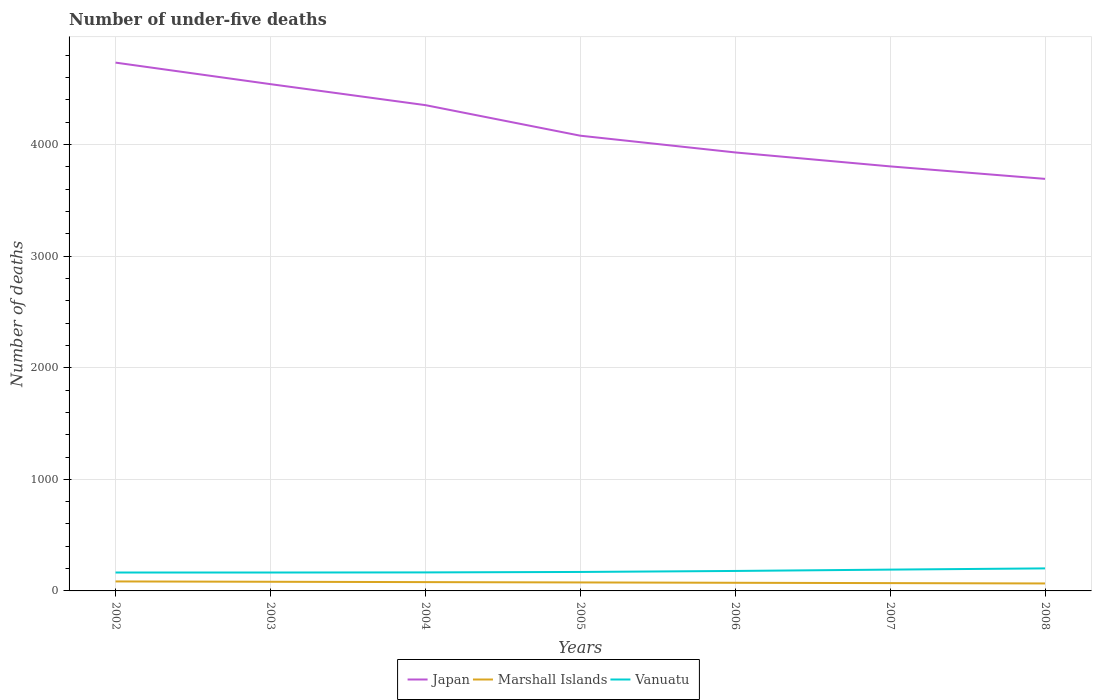Does the line corresponding to Japan intersect with the line corresponding to Vanuatu?
Offer a terse response. No. Across all years, what is the maximum number of under-five deaths in Marshall Islands?
Your answer should be compact. 67. In which year was the number of under-five deaths in Japan maximum?
Give a very brief answer. 2008. What is the difference between the highest and the second highest number of under-five deaths in Marshall Islands?
Your answer should be compact. 18. What is the difference between the highest and the lowest number of under-five deaths in Vanuatu?
Provide a short and direct response. 3. What is the difference between two consecutive major ticks on the Y-axis?
Offer a very short reply. 1000. Where does the legend appear in the graph?
Provide a succinct answer. Bottom center. How many legend labels are there?
Offer a terse response. 3. How are the legend labels stacked?
Your answer should be very brief. Horizontal. What is the title of the graph?
Make the answer very short. Number of under-five deaths. What is the label or title of the X-axis?
Give a very brief answer. Years. What is the label or title of the Y-axis?
Your response must be concise. Number of deaths. What is the Number of deaths of Japan in 2002?
Give a very brief answer. 4735. What is the Number of deaths of Vanuatu in 2002?
Your answer should be compact. 165. What is the Number of deaths of Japan in 2003?
Make the answer very short. 4542. What is the Number of deaths of Vanuatu in 2003?
Provide a succinct answer. 165. What is the Number of deaths of Japan in 2004?
Ensure brevity in your answer.  4354. What is the Number of deaths of Marshall Islands in 2004?
Provide a succinct answer. 79. What is the Number of deaths of Vanuatu in 2004?
Provide a short and direct response. 166. What is the Number of deaths in Japan in 2005?
Offer a very short reply. 4080. What is the Number of deaths in Marshall Islands in 2005?
Give a very brief answer. 76. What is the Number of deaths of Vanuatu in 2005?
Provide a succinct answer. 170. What is the Number of deaths in Japan in 2006?
Ensure brevity in your answer.  3930. What is the Number of deaths of Marshall Islands in 2006?
Provide a short and direct response. 73. What is the Number of deaths in Vanuatu in 2006?
Your answer should be compact. 179. What is the Number of deaths in Japan in 2007?
Your response must be concise. 3805. What is the Number of deaths of Vanuatu in 2007?
Give a very brief answer. 191. What is the Number of deaths in Japan in 2008?
Your answer should be compact. 3693. What is the Number of deaths in Vanuatu in 2008?
Your response must be concise. 202. Across all years, what is the maximum Number of deaths in Japan?
Ensure brevity in your answer.  4735. Across all years, what is the maximum Number of deaths of Vanuatu?
Your answer should be very brief. 202. Across all years, what is the minimum Number of deaths of Japan?
Ensure brevity in your answer.  3693. Across all years, what is the minimum Number of deaths in Vanuatu?
Your answer should be compact. 165. What is the total Number of deaths of Japan in the graph?
Provide a succinct answer. 2.91e+04. What is the total Number of deaths of Marshall Islands in the graph?
Your answer should be compact. 532. What is the total Number of deaths in Vanuatu in the graph?
Your answer should be very brief. 1238. What is the difference between the Number of deaths in Japan in 2002 and that in 2003?
Your response must be concise. 193. What is the difference between the Number of deaths in Japan in 2002 and that in 2004?
Your response must be concise. 381. What is the difference between the Number of deaths in Japan in 2002 and that in 2005?
Keep it short and to the point. 655. What is the difference between the Number of deaths in Vanuatu in 2002 and that in 2005?
Your answer should be very brief. -5. What is the difference between the Number of deaths of Japan in 2002 and that in 2006?
Ensure brevity in your answer.  805. What is the difference between the Number of deaths in Marshall Islands in 2002 and that in 2006?
Ensure brevity in your answer.  12. What is the difference between the Number of deaths in Vanuatu in 2002 and that in 2006?
Your answer should be very brief. -14. What is the difference between the Number of deaths in Japan in 2002 and that in 2007?
Make the answer very short. 930. What is the difference between the Number of deaths of Japan in 2002 and that in 2008?
Your response must be concise. 1042. What is the difference between the Number of deaths of Vanuatu in 2002 and that in 2008?
Provide a short and direct response. -37. What is the difference between the Number of deaths in Japan in 2003 and that in 2004?
Offer a terse response. 188. What is the difference between the Number of deaths of Vanuatu in 2003 and that in 2004?
Offer a terse response. -1. What is the difference between the Number of deaths of Japan in 2003 and that in 2005?
Keep it short and to the point. 462. What is the difference between the Number of deaths in Marshall Islands in 2003 and that in 2005?
Your response must be concise. 6. What is the difference between the Number of deaths of Vanuatu in 2003 and that in 2005?
Your answer should be very brief. -5. What is the difference between the Number of deaths of Japan in 2003 and that in 2006?
Give a very brief answer. 612. What is the difference between the Number of deaths in Marshall Islands in 2003 and that in 2006?
Your answer should be very brief. 9. What is the difference between the Number of deaths in Vanuatu in 2003 and that in 2006?
Provide a succinct answer. -14. What is the difference between the Number of deaths in Japan in 2003 and that in 2007?
Ensure brevity in your answer.  737. What is the difference between the Number of deaths of Vanuatu in 2003 and that in 2007?
Your response must be concise. -26. What is the difference between the Number of deaths of Japan in 2003 and that in 2008?
Your answer should be compact. 849. What is the difference between the Number of deaths of Vanuatu in 2003 and that in 2008?
Keep it short and to the point. -37. What is the difference between the Number of deaths of Japan in 2004 and that in 2005?
Give a very brief answer. 274. What is the difference between the Number of deaths of Japan in 2004 and that in 2006?
Make the answer very short. 424. What is the difference between the Number of deaths of Japan in 2004 and that in 2007?
Make the answer very short. 549. What is the difference between the Number of deaths of Marshall Islands in 2004 and that in 2007?
Provide a short and direct response. 9. What is the difference between the Number of deaths in Japan in 2004 and that in 2008?
Make the answer very short. 661. What is the difference between the Number of deaths of Marshall Islands in 2004 and that in 2008?
Make the answer very short. 12. What is the difference between the Number of deaths in Vanuatu in 2004 and that in 2008?
Offer a very short reply. -36. What is the difference between the Number of deaths of Japan in 2005 and that in 2006?
Ensure brevity in your answer.  150. What is the difference between the Number of deaths of Marshall Islands in 2005 and that in 2006?
Your response must be concise. 3. What is the difference between the Number of deaths in Vanuatu in 2005 and that in 2006?
Ensure brevity in your answer.  -9. What is the difference between the Number of deaths in Japan in 2005 and that in 2007?
Offer a terse response. 275. What is the difference between the Number of deaths of Vanuatu in 2005 and that in 2007?
Ensure brevity in your answer.  -21. What is the difference between the Number of deaths in Japan in 2005 and that in 2008?
Give a very brief answer. 387. What is the difference between the Number of deaths in Vanuatu in 2005 and that in 2008?
Offer a terse response. -32. What is the difference between the Number of deaths of Japan in 2006 and that in 2007?
Your answer should be compact. 125. What is the difference between the Number of deaths in Marshall Islands in 2006 and that in 2007?
Your response must be concise. 3. What is the difference between the Number of deaths of Japan in 2006 and that in 2008?
Offer a very short reply. 237. What is the difference between the Number of deaths of Japan in 2007 and that in 2008?
Your response must be concise. 112. What is the difference between the Number of deaths in Marshall Islands in 2007 and that in 2008?
Your response must be concise. 3. What is the difference between the Number of deaths in Vanuatu in 2007 and that in 2008?
Your response must be concise. -11. What is the difference between the Number of deaths in Japan in 2002 and the Number of deaths in Marshall Islands in 2003?
Provide a succinct answer. 4653. What is the difference between the Number of deaths in Japan in 2002 and the Number of deaths in Vanuatu in 2003?
Provide a short and direct response. 4570. What is the difference between the Number of deaths of Marshall Islands in 2002 and the Number of deaths of Vanuatu in 2003?
Your answer should be very brief. -80. What is the difference between the Number of deaths in Japan in 2002 and the Number of deaths in Marshall Islands in 2004?
Your answer should be very brief. 4656. What is the difference between the Number of deaths in Japan in 2002 and the Number of deaths in Vanuatu in 2004?
Your response must be concise. 4569. What is the difference between the Number of deaths in Marshall Islands in 2002 and the Number of deaths in Vanuatu in 2004?
Your answer should be very brief. -81. What is the difference between the Number of deaths of Japan in 2002 and the Number of deaths of Marshall Islands in 2005?
Provide a short and direct response. 4659. What is the difference between the Number of deaths of Japan in 2002 and the Number of deaths of Vanuatu in 2005?
Make the answer very short. 4565. What is the difference between the Number of deaths of Marshall Islands in 2002 and the Number of deaths of Vanuatu in 2005?
Give a very brief answer. -85. What is the difference between the Number of deaths of Japan in 2002 and the Number of deaths of Marshall Islands in 2006?
Keep it short and to the point. 4662. What is the difference between the Number of deaths in Japan in 2002 and the Number of deaths in Vanuatu in 2006?
Provide a succinct answer. 4556. What is the difference between the Number of deaths in Marshall Islands in 2002 and the Number of deaths in Vanuatu in 2006?
Give a very brief answer. -94. What is the difference between the Number of deaths in Japan in 2002 and the Number of deaths in Marshall Islands in 2007?
Keep it short and to the point. 4665. What is the difference between the Number of deaths of Japan in 2002 and the Number of deaths of Vanuatu in 2007?
Offer a terse response. 4544. What is the difference between the Number of deaths in Marshall Islands in 2002 and the Number of deaths in Vanuatu in 2007?
Make the answer very short. -106. What is the difference between the Number of deaths of Japan in 2002 and the Number of deaths of Marshall Islands in 2008?
Make the answer very short. 4668. What is the difference between the Number of deaths of Japan in 2002 and the Number of deaths of Vanuatu in 2008?
Ensure brevity in your answer.  4533. What is the difference between the Number of deaths of Marshall Islands in 2002 and the Number of deaths of Vanuatu in 2008?
Your response must be concise. -117. What is the difference between the Number of deaths in Japan in 2003 and the Number of deaths in Marshall Islands in 2004?
Offer a terse response. 4463. What is the difference between the Number of deaths in Japan in 2003 and the Number of deaths in Vanuatu in 2004?
Give a very brief answer. 4376. What is the difference between the Number of deaths in Marshall Islands in 2003 and the Number of deaths in Vanuatu in 2004?
Ensure brevity in your answer.  -84. What is the difference between the Number of deaths in Japan in 2003 and the Number of deaths in Marshall Islands in 2005?
Provide a short and direct response. 4466. What is the difference between the Number of deaths of Japan in 2003 and the Number of deaths of Vanuatu in 2005?
Your response must be concise. 4372. What is the difference between the Number of deaths of Marshall Islands in 2003 and the Number of deaths of Vanuatu in 2005?
Give a very brief answer. -88. What is the difference between the Number of deaths in Japan in 2003 and the Number of deaths in Marshall Islands in 2006?
Ensure brevity in your answer.  4469. What is the difference between the Number of deaths in Japan in 2003 and the Number of deaths in Vanuatu in 2006?
Your response must be concise. 4363. What is the difference between the Number of deaths in Marshall Islands in 2003 and the Number of deaths in Vanuatu in 2006?
Keep it short and to the point. -97. What is the difference between the Number of deaths of Japan in 2003 and the Number of deaths of Marshall Islands in 2007?
Give a very brief answer. 4472. What is the difference between the Number of deaths of Japan in 2003 and the Number of deaths of Vanuatu in 2007?
Provide a short and direct response. 4351. What is the difference between the Number of deaths in Marshall Islands in 2003 and the Number of deaths in Vanuatu in 2007?
Offer a very short reply. -109. What is the difference between the Number of deaths in Japan in 2003 and the Number of deaths in Marshall Islands in 2008?
Keep it short and to the point. 4475. What is the difference between the Number of deaths in Japan in 2003 and the Number of deaths in Vanuatu in 2008?
Keep it short and to the point. 4340. What is the difference between the Number of deaths in Marshall Islands in 2003 and the Number of deaths in Vanuatu in 2008?
Offer a terse response. -120. What is the difference between the Number of deaths of Japan in 2004 and the Number of deaths of Marshall Islands in 2005?
Ensure brevity in your answer.  4278. What is the difference between the Number of deaths in Japan in 2004 and the Number of deaths in Vanuatu in 2005?
Give a very brief answer. 4184. What is the difference between the Number of deaths of Marshall Islands in 2004 and the Number of deaths of Vanuatu in 2005?
Make the answer very short. -91. What is the difference between the Number of deaths in Japan in 2004 and the Number of deaths in Marshall Islands in 2006?
Offer a very short reply. 4281. What is the difference between the Number of deaths of Japan in 2004 and the Number of deaths of Vanuatu in 2006?
Your answer should be compact. 4175. What is the difference between the Number of deaths of Marshall Islands in 2004 and the Number of deaths of Vanuatu in 2006?
Provide a succinct answer. -100. What is the difference between the Number of deaths in Japan in 2004 and the Number of deaths in Marshall Islands in 2007?
Your answer should be compact. 4284. What is the difference between the Number of deaths in Japan in 2004 and the Number of deaths in Vanuatu in 2007?
Provide a short and direct response. 4163. What is the difference between the Number of deaths in Marshall Islands in 2004 and the Number of deaths in Vanuatu in 2007?
Your answer should be very brief. -112. What is the difference between the Number of deaths in Japan in 2004 and the Number of deaths in Marshall Islands in 2008?
Keep it short and to the point. 4287. What is the difference between the Number of deaths of Japan in 2004 and the Number of deaths of Vanuatu in 2008?
Make the answer very short. 4152. What is the difference between the Number of deaths in Marshall Islands in 2004 and the Number of deaths in Vanuatu in 2008?
Make the answer very short. -123. What is the difference between the Number of deaths in Japan in 2005 and the Number of deaths in Marshall Islands in 2006?
Your answer should be very brief. 4007. What is the difference between the Number of deaths in Japan in 2005 and the Number of deaths in Vanuatu in 2006?
Give a very brief answer. 3901. What is the difference between the Number of deaths in Marshall Islands in 2005 and the Number of deaths in Vanuatu in 2006?
Your answer should be very brief. -103. What is the difference between the Number of deaths in Japan in 2005 and the Number of deaths in Marshall Islands in 2007?
Your answer should be compact. 4010. What is the difference between the Number of deaths of Japan in 2005 and the Number of deaths of Vanuatu in 2007?
Keep it short and to the point. 3889. What is the difference between the Number of deaths of Marshall Islands in 2005 and the Number of deaths of Vanuatu in 2007?
Your answer should be compact. -115. What is the difference between the Number of deaths of Japan in 2005 and the Number of deaths of Marshall Islands in 2008?
Make the answer very short. 4013. What is the difference between the Number of deaths of Japan in 2005 and the Number of deaths of Vanuatu in 2008?
Provide a succinct answer. 3878. What is the difference between the Number of deaths in Marshall Islands in 2005 and the Number of deaths in Vanuatu in 2008?
Your answer should be compact. -126. What is the difference between the Number of deaths of Japan in 2006 and the Number of deaths of Marshall Islands in 2007?
Provide a succinct answer. 3860. What is the difference between the Number of deaths in Japan in 2006 and the Number of deaths in Vanuatu in 2007?
Your answer should be very brief. 3739. What is the difference between the Number of deaths in Marshall Islands in 2006 and the Number of deaths in Vanuatu in 2007?
Provide a succinct answer. -118. What is the difference between the Number of deaths of Japan in 2006 and the Number of deaths of Marshall Islands in 2008?
Offer a terse response. 3863. What is the difference between the Number of deaths in Japan in 2006 and the Number of deaths in Vanuatu in 2008?
Your answer should be compact. 3728. What is the difference between the Number of deaths in Marshall Islands in 2006 and the Number of deaths in Vanuatu in 2008?
Make the answer very short. -129. What is the difference between the Number of deaths in Japan in 2007 and the Number of deaths in Marshall Islands in 2008?
Give a very brief answer. 3738. What is the difference between the Number of deaths in Japan in 2007 and the Number of deaths in Vanuatu in 2008?
Provide a succinct answer. 3603. What is the difference between the Number of deaths of Marshall Islands in 2007 and the Number of deaths of Vanuatu in 2008?
Offer a terse response. -132. What is the average Number of deaths of Japan per year?
Provide a succinct answer. 4162.71. What is the average Number of deaths in Marshall Islands per year?
Offer a very short reply. 76. What is the average Number of deaths in Vanuatu per year?
Offer a terse response. 176.86. In the year 2002, what is the difference between the Number of deaths of Japan and Number of deaths of Marshall Islands?
Give a very brief answer. 4650. In the year 2002, what is the difference between the Number of deaths of Japan and Number of deaths of Vanuatu?
Offer a terse response. 4570. In the year 2002, what is the difference between the Number of deaths of Marshall Islands and Number of deaths of Vanuatu?
Offer a very short reply. -80. In the year 2003, what is the difference between the Number of deaths in Japan and Number of deaths in Marshall Islands?
Your answer should be compact. 4460. In the year 2003, what is the difference between the Number of deaths in Japan and Number of deaths in Vanuatu?
Give a very brief answer. 4377. In the year 2003, what is the difference between the Number of deaths in Marshall Islands and Number of deaths in Vanuatu?
Offer a terse response. -83. In the year 2004, what is the difference between the Number of deaths in Japan and Number of deaths in Marshall Islands?
Provide a succinct answer. 4275. In the year 2004, what is the difference between the Number of deaths of Japan and Number of deaths of Vanuatu?
Your answer should be compact. 4188. In the year 2004, what is the difference between the Number of deaths of Marshall Islands and Number of deaths of Vanuatu?
Offer a very short reply. -87. In the year 2005, what is the difference between the Number of deaths in Japan and Number of deaths in Marshall Islands?
Offer a very short reply. 4004. In the year 2005, what is the difference between the Number of deaths of Japan and Number of deaths of Vanuatu?
Ensure brevity in your answer.  3910. In the year 2005, what is the difference between the Number of deaths in Marshall Islands and Number of deaths in Vanuatu?
Offer a terse response. -94. In the year 2006, what is the difference between the Number of deaths of Japan and Number of deaths of Marshall Islands?
Keep it short and to the point. 3857. In the year 2006, what is the difference between the Number of deaths in Japan and Number of deaths in Vanuatu?
Provide a succinct answer. 3751. In the year 2006, what is the difference between the Number of deaths of Marshall Islands and Number of deaths of Vanuatu?
Provide a succinct answer. -106. In the year 2007, what is the difference between the Number of deaths of Japan and Number of deaths of Marshall Islands?
Provide a succinct answer. 3735. In the year 2007, what is the difference between the Number of deaths of Japan and Number of deaths of Vanuatu?
Provide a short and direct response. 3614. In the year 2007, what is the difference between the Number of deaths of Marshall Islands and Number of deaths of Vanuatu?
Make the answer very short. -121. In the year 2008, what is the difference between the Number of deaths in Japan and Number of deaths in Marshall Islands?
Your answer should be very brief. 3626. In the year 2008, what is the difference between the Number of deaths of Japan and Number of deaths of Vanuatu?
Make the answer very short. 3491. In the year 2008, what is the difference between the Number of deaths of Marshall Islands and Number of deaths of Vanuatu?
Make the answer very short. -135. What is the ratio of the Number of deaths of Japan in 2002 to that in 2003?
Provide a succinct answer. 1.04. What is the ratio of the Number of deaths in Marshall Islands in 2002 to that in 2003?
Offer a very short reply. 1.04. What is the ratio of the Number of deaths of Vanuatu in 2002 to that in 2003?
Make the answer very short. 1. What is the ratio of the Number of deaths of Japan in 2002 to that in 2004?
Your response must be concise. 1.09. What is the ratio of the Number of deaths of Marshall Islands in 2002 to that in 2004?
Provide a short and direct response. 1.08. What is the ratio of the Number of deaths in Vanuatu in 2002 to that in 2004?
Your answer should be very brief. 0.99. What is the ratio of the Number of deaths in Japan in 2002 to that in 2005?
Provide a short and direct response. 1.16. What is the ratio of the Number of deaths of Marshall Islands in 2002 to that in 2005?
Your answer should be very brief. 1.12. What is the ratio of the Number of deaths in Vanuatu in 2002 to that in 2005?
Offer a very short reply. 0.97. What is the ratio of the Number of deaths of Japan in 2002 to that in 2006?
Offer a very short reply. 1.2. What is the ratio of the Number of deaths in Marshall Islands in 2002 to that in 2006?
Your answer should be very brief. 1.16. What is the ratio of the Number of deaths of Vanuatu in 2002 to that in 2006?
Give a very brief answer. 0.92. What is the ratio of the Number of deaths of Japan in 2002 to that in 2007?
Provide a succinct answer. 1.24. What is the ratio of the Number of deaths in Marshall Islands in 2002 to that in 2007?
Provide a short and direct response. 1.21. What is the ratio of the Number of deaths in Vanuatu in 2002 to that in 2007?
Offer a very short reply. 0.86. What is the ratio of the Number of deaths in Japan in 2002 to that in 2008?
Provide a short and direct response. 1.28. What is the ratio of the Number of deaths of Marshall Islands in 2002 to that in 2008?
Provide a short and direct response. 1.27. What is the ratio of the Number of deaths of Vanuatu in 2002 to that in 2008?
Offer a very short reply. 0.82. What is the ratio of the Number of deaths of Japan in 2003 to that in 2004?
Your answer should be compact. 1.04. What is the ratio of the Number of deaths of Marshall Islands in 2003 to that in 2004?
Offer a terse response. 1.04. What is the ratio of the Number of deaths of Vanuatu in 2003 to that in 2004?
Keep it short and to the point. 0.99. What is the ratio of the Number of deaths of Japan in 2003 to that in 2005?
Keep it short and to the point. 1.11. What is the ratio of the Number of deaths in Marshall Islands in 2003 to that in 2005?
Offer a terse response. 1.08. What is the ratio of the Number of deaths of Vanuatu in 2003 to that in 2005?
Give a very brief answer. 0.97. What is the ratio of the Number of deaths in Japan in 2003 to that in 2006?
Offer a terse response. 1.16. What is the ratio of the Number of deaths of Marshall Islands in 2003 to that in 2006?
Provide a short and direct response. 1.12. What is the ratio of the Number of deaths in Vanuatu in 2003 to that in 2006?
Offer a very short reply. 0.92. What is the ratio of the Number of deaths of Japan in 2003 to that in 2007?
Your response must be concise. 1.19. What is the ratio of the Number of deaths in Marshall Islands in 2003 to that in 2007?
Make the answer very short. 1.17. What is the ratio of the Number of deaths in Vanuatu in 2003 to that in 2007?
Offer a terse response. 0.86. What is the ratio of the Number of deaths in Japan in 2003 to that in 2008?
Your answer should be very brief. 1.23. What is the ratio of the Number of deaths in Marshall Islands in 2003 to that in 2008?
Your answer should be very brief. 1.22. What is the ratio of the Number of deaths of Vanuatu in 2003 to that in 2008?
Ensure brevity in your answer.  0.82. What is the ratio of the Number of deaths in Japan in 2004 to that in 2005?
Make the answer very short. 1.07. What is the ratio of the Number of deaths in Marshall Islands in 2004 to that in 2005?
Offer a very short reply. 1.04. What is the ratio of the Number of deaths in Vanuatu in 2004 to that in 2005?
Offer a very short reply. 0.98. What is the ratio of the Number of deaths of Japan in 2004 to that in 2006?
Offer a terse response. 1.11. What is the ratio of the Number of deaths of Marshall Islands in 2004 to that in 2006?
Provide a succinct answer. 1.08. What is the ratio of the Number of deaths in Vanuatu in 2004 to that in 2006?
Keep it short and to the point. 0.93. What is the ratio of the Number of deaths of Japan in 2004 to that in 2007?
Provide a short and direct response. 1.14. What is the ratio of the Number of deaths in Marshall Islands in 2004 to that in 2007?
Your answer should be very brief. 1.13. What is the ratio of the Number of deaths of Vanuatu in 2004 to that in 2007?
Make the answer very short. 0.87. What is the ratio of the Number of deaths in Japan in 2004 to that in 2008?
Make the answer very short. 1.18. What is the ratio of the Number of deaths of Marshall Islands in 2004 to that in 2008?
Your answer should be compact. 1.18. What is the ratio of the Number of deaths in Vanuatu in 2004 to that in 2008?
Offer a terse response. 0.82. What is the ratio of the Number of deaths of Japan in 2005 to that in 2006?
Your answer should be very brief. 1.04. What is the ratio of the Number of deaths of Marshall Islands in 2005 to that in 2006?
Your answer should be very brief. 1.04. What is the ratio of the Number of deaths of Vanuatu in 2005 to that in 2006?
Offer a very short reply. 0.95. What is the ratio of the Number of deaths in Japan in 2005 to that in 2007?
Your response must be concise. 1.07. What is the ratio of the Number of deaths in Marshall Islands in 2005 to that in 2007?
Give a very brief answer. 1.09. What is the ratio of the Number of deaths of Vanuatu in 2005 to that in 2007?
Give a very brief answer. 0.89. What is the ratio of the Number of deaths in Japan in 2005 to that in 2008?
Give a very brief answer. 1.1. What is the ratio of the Number of deaths in Marshall Islands in 2005 to that in 2008?
Make the answer very short. 1.13. What is the ratio of the Number of deaths in Vanuatu in 2005 to that in 2008?
Make the answer very short. 0.84. What is the ratio of the Number of deaths of Japan in 2006 to that in 2007?
Give a very brief answer. 1.03. What is the ratio of the Number of deaths in Marshall Islands in 2006 to that in 2007?
Your response must be concise. 1.04. What is the ratio of the Number of deaths of Vanuatu in 2006 to that in 2007?
Offer a terse response. 0.94. What is the ratio of the Number of deaths in Japan in 2006 to that in 2008?
Provide a short and direct response. 1.06. What is the ratio of the Number of deaths of Marshall Islands in 2006 to that in 2008?
Offer a terse response. 1.09. What is the ratio of the Number of deaths in Vanuatu in 2006 to that in 2008?
Provide a succinct answer. 0.89. What is the ratio of the Number of deaths of Japan in 2007 to that in 2008?
Provide a succinct answer. 1.03. What is the ratio of the Number of deaths of Marshall Islands in 2007 to that in 2008?
Provide a short and direct response. 1.04. What is the ratio of the Number of deaths of Vanuatu in 2007 to that in 2008?
Keep it short and to the point. 0.95. What is the difference between the highest and the second highest Number of deaths in Japan?
Keep it short and to the point. 193. What is the difference between the highest and the second highest Number of deaths of Marshall Islands?
Give a very brief answer. 3. What is the difference between the highest and the second highest Number of deaths in Vanuatu?
Make the answer very short. 11. What is the difference between the highest and the lowest Number of deaths of Japan?
Your answer should be very brief. 1042. 